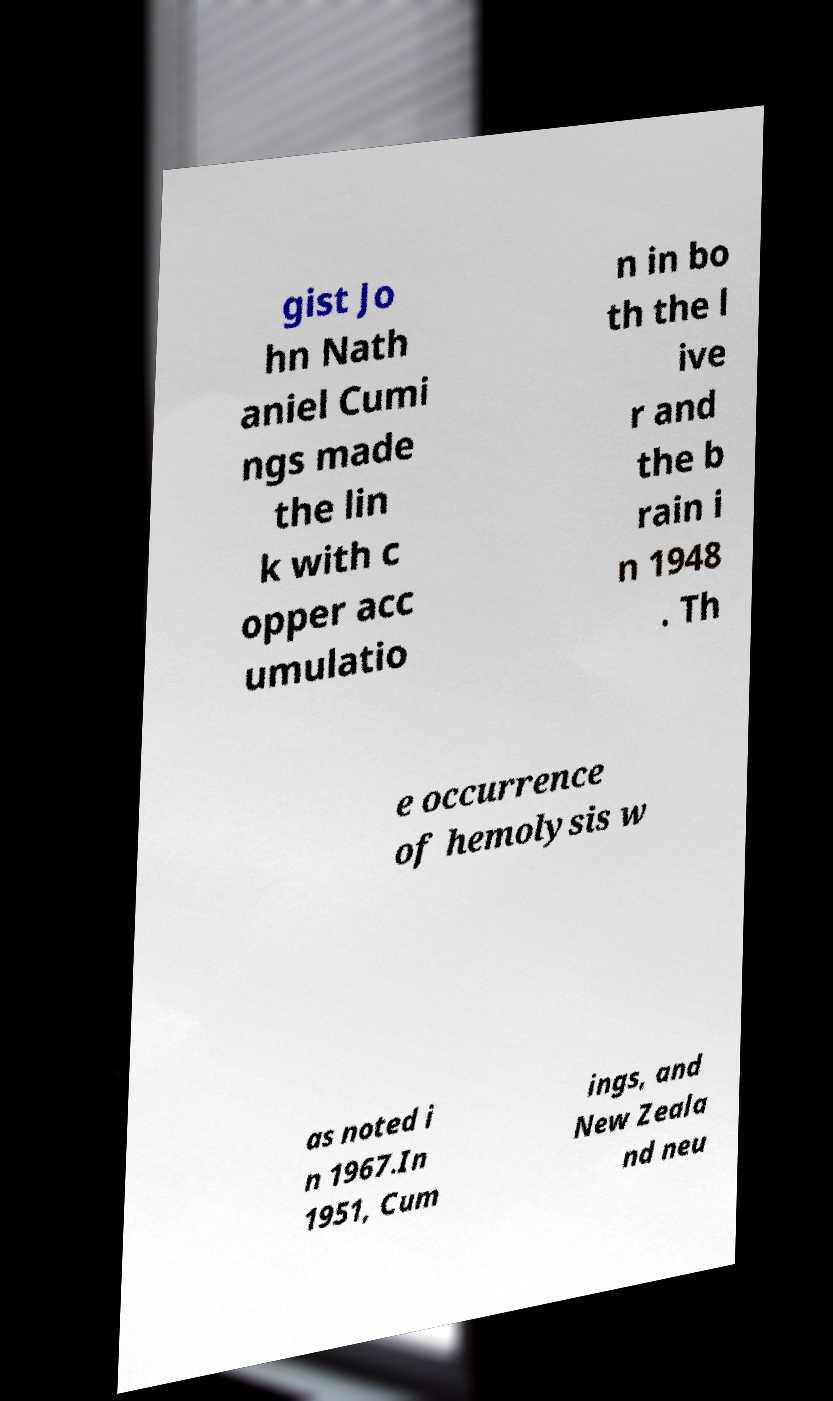Please read and relay the text visible in this image. What does it say? gist Jo hn Nath aniel Cumi ngs made the lin k with c opper acc umulatio n in bo th the l ive r and the b rain i n 1948 . Th e occurrence of hemolysis w as noted i n 1967.In 1951, Cum ings, and New Zeala nd neu 